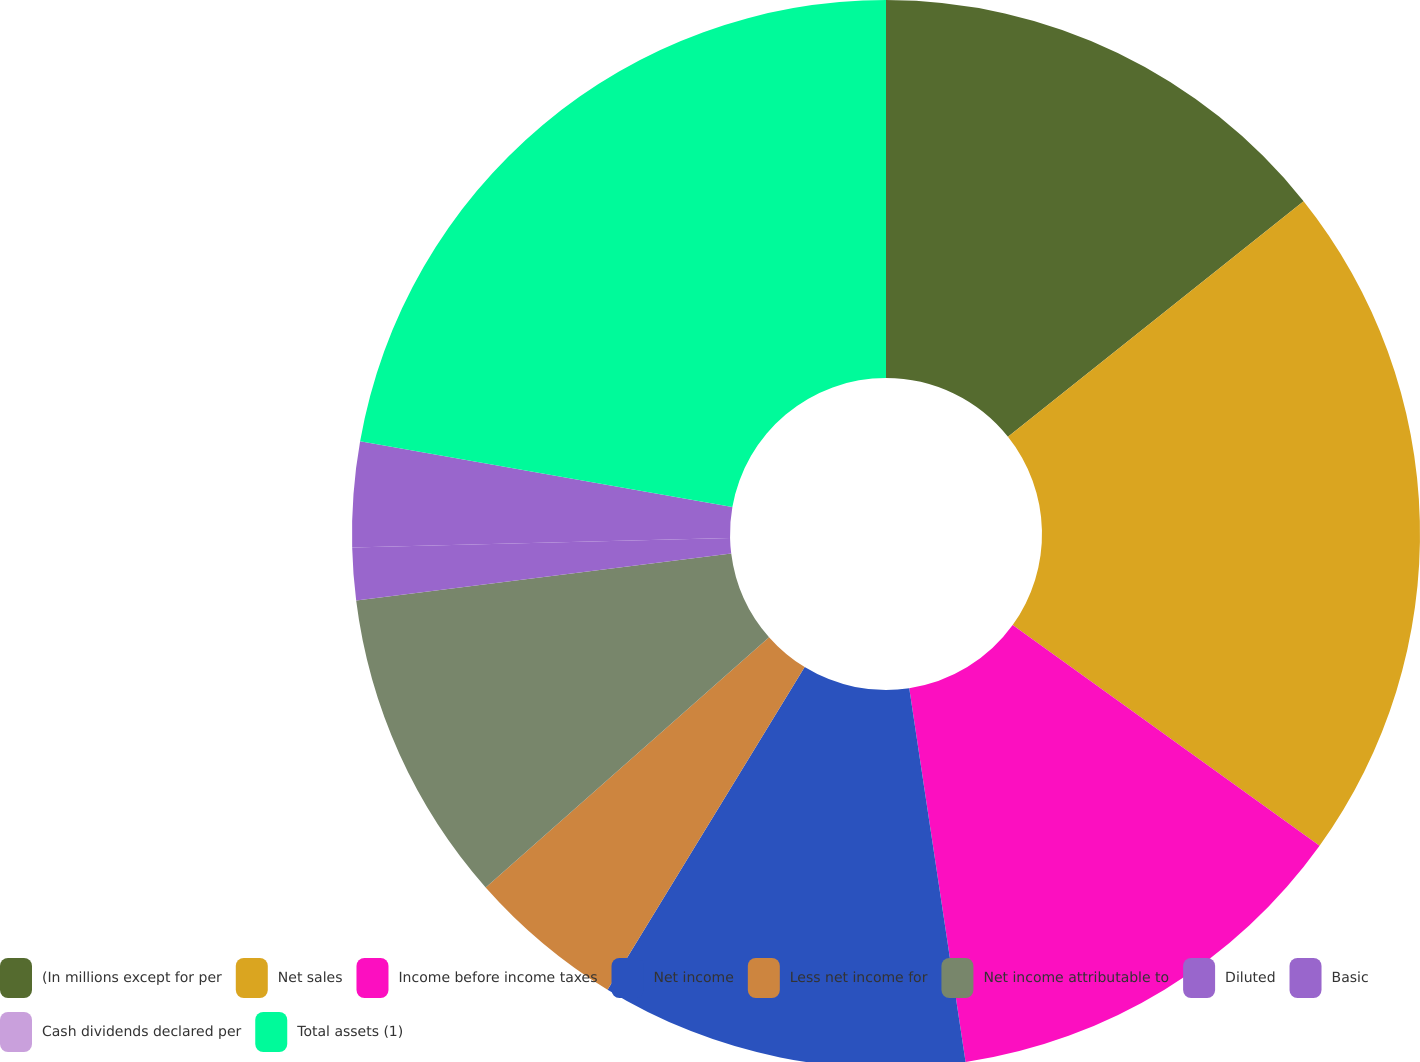<chart> <loc_0><loc_0><loc_500><loc_500><pie_chart><fcel>(In millions except for per<fcel>Net sales<fcel>Income before income taxes<fcel>Net income<fcel>Less net income for<fcel>Net income attributable to<fcel>Diluted<fcel>Basic<fcel>Cash dividends declared per<fcel>Total assets (1)<nl><fcel>14.29%<fcel>20.63%<fcel>12.7%<fcel>11.11%<fcel>4.76%<fcel>9.52%<fcel>1.59%<fcel>3.18%<fcel>0.0%<fcel>22.22%<nl></chart> 